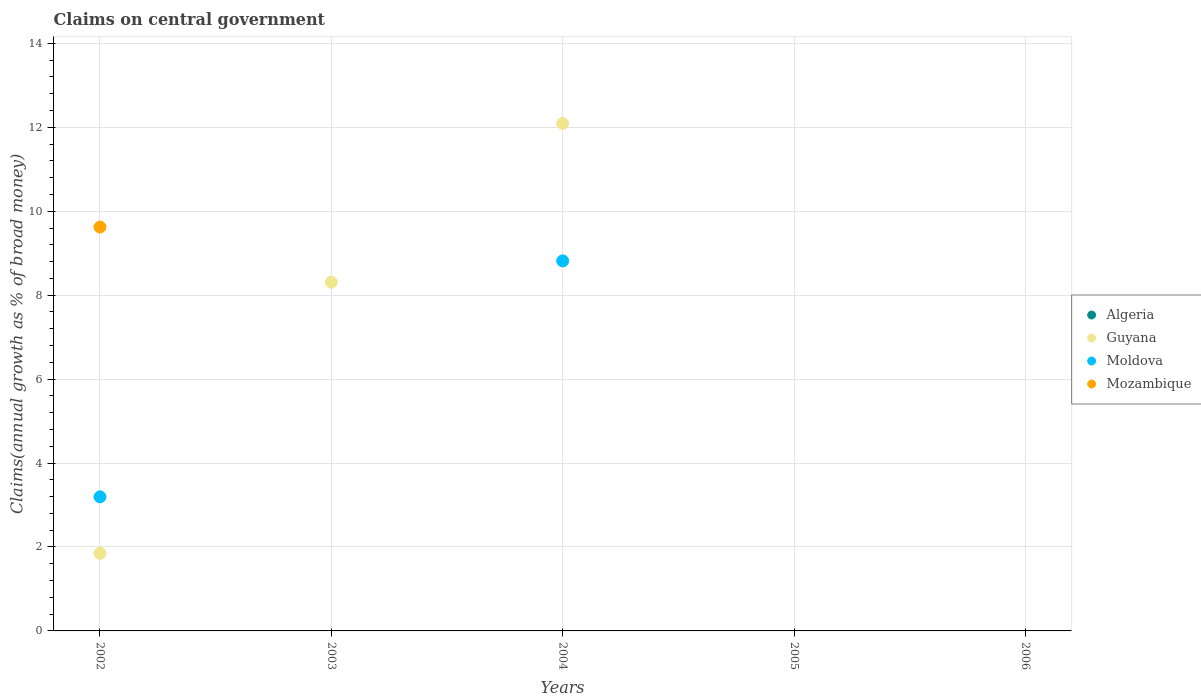How many different coloured dotlines are there?
Your response must be concise. 3. Is the number of dotlines equal to the number of legend labels?
Your answer should be very brief. No. Across all years, what is the maximum percentage of broad money claimed on centeral government in Moldova?
Your response must be concise. 8.82. Across all years, what is the minimum percentage of broad money claimed on centeral government in Moldova?
Give a very brief answer. 0. In which year was the percentage of broad money claimed on centeral government in Moldova maximum?
Your response must be concise. 2004. What is the total percentage of broad money claimed on centeral government in Moldova in the graph?
Your response must be concise. 12.01. What is the difference between the percentage of broad money claimed on centeral government in Moldova in 2006 and the percentage of broad money claimed on centeral government in Algeria in 2002?
Your answer should be very brief. 0. What is the average percentage of broad money claimed on centeral government in Mozambique per year?
Ensure brevity in your answer.  1.92. In the year 2002, what is the difference between the percentage of broad money claimed on centeral government in Guyana and percentage of broad money claimed on centeral government in Mozambique?
Offer a very short reply. -7.77. In how many years, is the percentage of broad money claimed on centeral government in Mozambique greater than 2 %?
Provide a short and direct response. 1. What is the difference between the highest and the lowest percentage of broad money claimed on centeral government in Mozambique?
Offer a terse response. 9.62. In how many years, is the percentage of broad money claimed on centeral government in Moldova greater than the average percentage of broad money claimed on centeral government in Moldova taken over all years?
Offer a very short reply. 2. Is the sum of the percentage of broad money claimed on centeral government in Guyana in 2002 and 2003 greater than the maximum percentage of broad money claimed on centeral government in Algeria across all years?
Offer a terse response. Yes. Is it the case that in every year, the sum of the percentage of broad money claimed on centeral government in Moldova and percentage of broad money claimed on centeral government in Mozambique  is greater than the sum of percentage of broad money claimed on centeral government in Algeria and percentage of broad money claimed on centeral government in Guyana?
Offer a very short reply. No. Is it the case that in every year, the sum of the percentage of broad money claimed on centeral government in Algeria and percentage of broad money claimed on centeral government in Moldova  is greater than the percentage of broad money claimed on centeral government in Mozambique?
Provide a succinct answer. No. Is the percentage of broad money claimed on centeral government in Algeria strictly greater than the percentage of broad money claimed on centeral government in Guyana over the years?
Give a very brief answer. No. Is the percentage of broad money claimed on centeral government in Guyana strictly less than the percentage of broad money claimed on centeral government in Algeria over the years?
Provide a short and direct response. No. How many dotlines are there?
Keep it short and to the point. 3. How many years are there in the graph?
Keep it short and to the point. 5. What is the difference between two consecutive major ticks on the Y-axis?
Ensure brevity in your answer.  2. Does the graph contain grids?
Give a very brief answer. Yes. How are the legend labels stacked?
Keep it short and to the point. Vertical. What is the title of the graph?
Ensure brevity in your answer.  Claims on central government. Does "Hungary" appear as one of the legend labels in the graph?
Your response must be concise. No. What is the label or title of the X-axis?
Give a very brief answer. Years. What is the label or title of the Y-axis?
Your answer should be compact. Claims(annual growth as % of broad money). What is the Claims(annual growth as % of broad money) of Guyana in 2002?
Ensure brevity in your answer.  1.85. What is the Claims(annual growth as % of broad money) of Moldova in 2002?
Your answer should be compact. 3.19. What is the Claims(annual growth as % of broad money) of Mozambique in 2002?
Keep it short and to the point. 9.62. What is the Claims(annual growth as % of broad money) of Guyana in 2003?
Give a very brief answer. 8.31. What is the Claims(annual growth as % of broad money) of Moldova in 2003?
Give a very brief answer. 0. What is the Claims(annual growth as % of broad money) in Guyana in 2004?
Provide a succinct answer. 12.09. What is the Claims(annual growth as % of broad money) of Moldova in 2004?
Keep it short and to the point. 8.82. What is the Claims(annual growth as % of broad money) of Mozambique in 2004?
Offer a terse response. 0. What is the Claims(annual growth as % of broad money) in Algeria in 2005?
Keep it short and to the point. 0. What is the Claims(annual growth as % of broad money) in Guyana in 2005?
Offer a terse response. 0. What is the Claims(annual growth as % of broad money) in Mozambique in 2005?
Offer a very short reply. 0. What is the Claims(annual growth as % of broad money) of Guyana in 2006?
Provide a short and direct response. 0. What is the Claims(annual growth as % of broad money) in Mozambique in 2006?
Your response must be concise. 0. Across all years, what is the maximum Claims(annual growth as % of broad money) of Guyana?
Ensure brevity in your answer.  12.09. Across all years, what is the maximum Claims(annual growth as % of broad money) of Moldova?
Provide a short and direct response. 8.82. Across all years, what is the maximum Claims(annual growth as % of broad money) of Mozambique?
Make the answer very short. 9.62. Across all years, what is the minimum Claims(annual growth as % of broad money) of Guyana?
Keep it short and to the point. 0. Across all years, what is the minimum Claims(annual growth as % of broad money) in Moldova?
Provide a short and direct response. 0. What is the total Claims(annual growth as % of broad money) in Guyana in the graph?
Your answer should be very brief. 22.25. What is the total Claims(annual growth as % of broad money) of Moldova in the graph?
Offer a terse response. 12.01. What is the total Claims(annual growth as % of broad money) of Mozambique in the graph?
Keep it short and to the point. 9.62. What is the difference between the Claims(annual growth as % of broad money) in Guyana in 2002 and that in 2003?
Offer a terse response. -6.46. What is the difference between the Claims(annual growth as % of broad money) of Guyana in 2002 and that in 2004?
Your response must be concise. -10.24. What is the difference between the Claims(annual growth as % of broad money) of Moldova in 2002 and that in 2004?
Ensure brevity in your answer.  -5.62. What is the difference between the Claims(annual growth as % of broad money) of Guyana in 2003 and that in 2004?
Your response must be concise. -3.78. What is the difference between the Claims(annual growth as % of broad money) in Guyana in 2002 and the Claims(annual growth as % of broad money) in Moldova in 2004?
Offer a terse response. -6.97. What is the difference between the Claims(annual growth as % of broad money) in Guyana in 2003 and the Claims(annual growth as % of broad money) in Moldova in 2004?
Your answer should be very brief. -0.51. What is the average Claims(annual growth as % of broad money) of Algeria per year?
Your answer should be compact. 0. What is the average Claims(annual growth as % of broad money) of Guyana per year?
Keep it short and to the point. 4.45. What is the average Claims(annual growth as % of broad money) of Moldova per year?
Ensure brevity in your answer.  2.4. What is the average Claims(annual growth as % of broad money) of Mozambique per year?
Your response must be concise. 1.92. In the year 2002, what is the difference between the Claims(annual growth as % of broad money) of Guyana and Claims(annual growth as % of broad money) of Moldova?
Offer a terse response. -1.34. In the year 2002, what is the difference between the Claims(annual growth as % of broad money) of Guyana and Claims(annual growth as % of broad money) of Mozambique?
Keep it short and to the point. -7.77. In the year 2002, what is the difference between the Claims(annual growth as % of broad money) of Moldova and Claims(annual growth as % of broad money) of Mozambique?
Your response must be concise. -6.43. In the year 2004, what is the difference between the Claims(annual growth as % of broad money) in Guyana and Claims(annual growth as % of broad money) in Moldova?
Provide a succinct answer. 3.27. What is the ratio of the Claims(annual growth as % of broad money) of Guyana in 2002 to that in 2003?
Provide a short and direct response. 0.22. What is the ratio of the Claims(annual growth as % of broad money) in Guyana in 2002 to that in 2004?
Provide a short and direct response. 0.15. What is the ratio of the Claims(annual growth as % of broad money) in Moldova in 2002 to that in 2004?
Provide a short and direct response. 0.36. What is the ratio of the Claims(annual growth as % of broad money) in Guyana in 2003 to that in 2004?
Ensure brevity in your answer.  0.69. What is the difference between the highest and the second highest Claims(annual growth as % of broad money) of Guyana?
Your response must be concise. 3.78. What is the difference between the highest and the lowest Claims(annual growth as % of broad money) in Guyana?
Offer a very short reply. 12.09. What is the difference between the highest and the lowest Claims(annual growth as % of broad money) in Moldova?
Your answer should be compact. 8.82. What is the difference between the highest and the lowest Claims(annual growth as % of broad money) of Mozambique?
Your response must be concise. 9.62. 